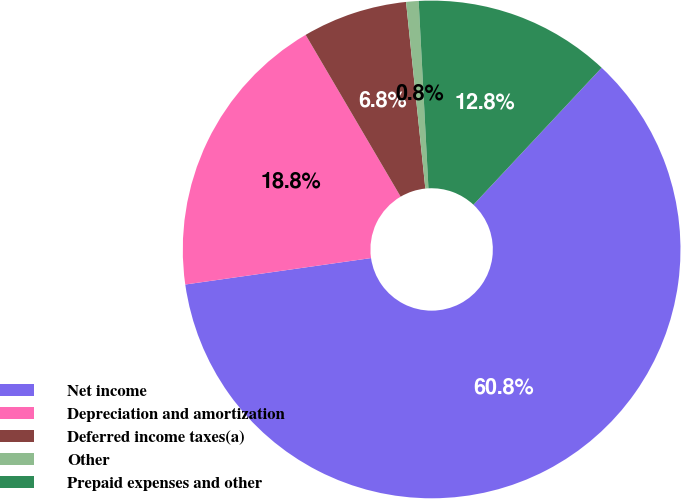Convert chart to OTSL. <chart><loc_0><loc_0><loc_500><loc_500><pie_chart><fcel>Net income<fcel>Depreciation and amortization<fcel>Deferred income taxes(a)<fcel>Other<fcel>Prepaid expenses and other<nl><fcel>60.78%<fcel>18.8%<fcel>6.81%<fcel>0.81%<fcel>12.8%<nl></chart> 